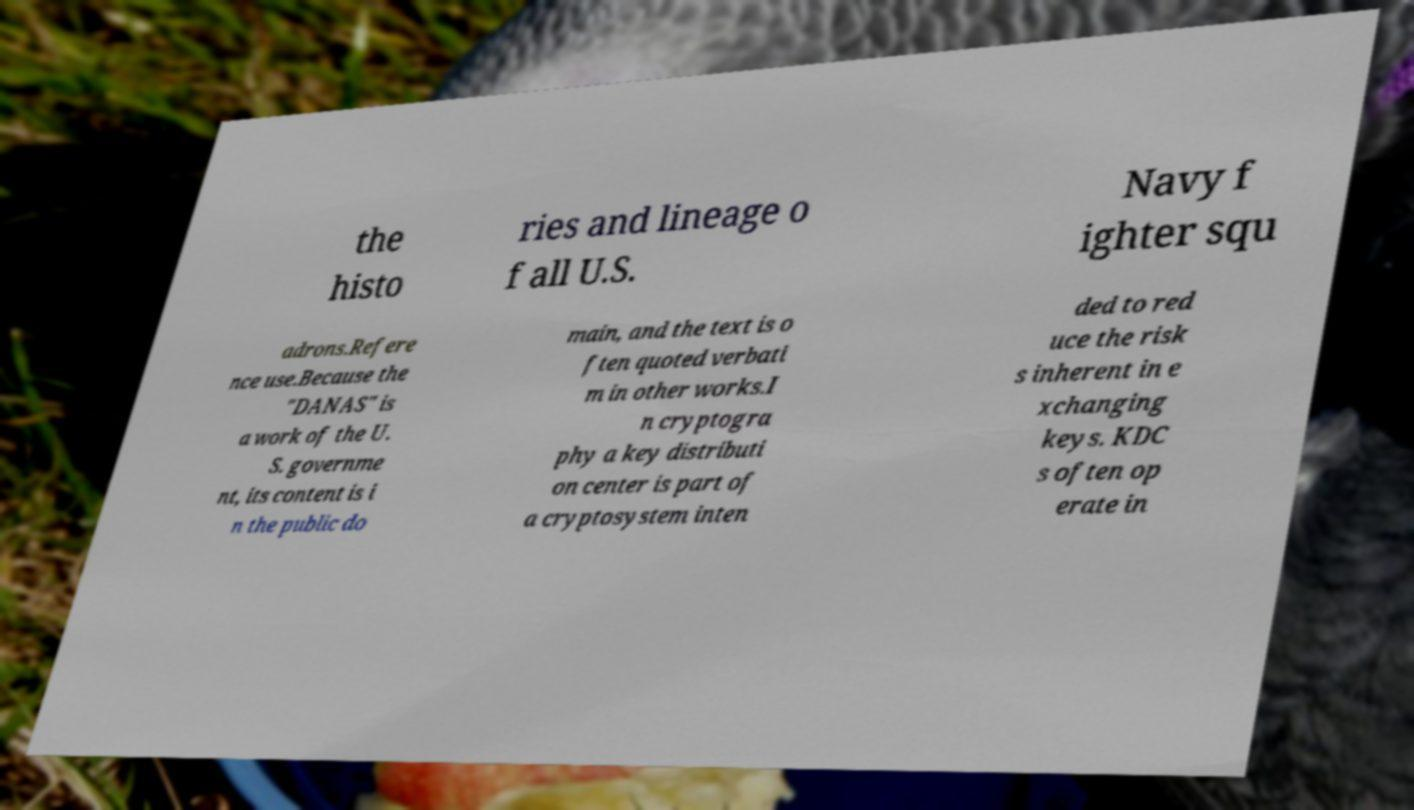Could you extract and type out the text from this image? the histo ries and lineage o f all U.S. Navy f ighter squ adrons.Refere nce use.Because the "DANAS" is a work of the U. S. governme nt, its content is i n the public do main, and the text is o ften quoted verbati m in other works.I n cryptogra phy a key distributi on center is part of a cryptosystem inten ded to red uce the risk s inherent in e xchanging keys. KDC s often op erate in 